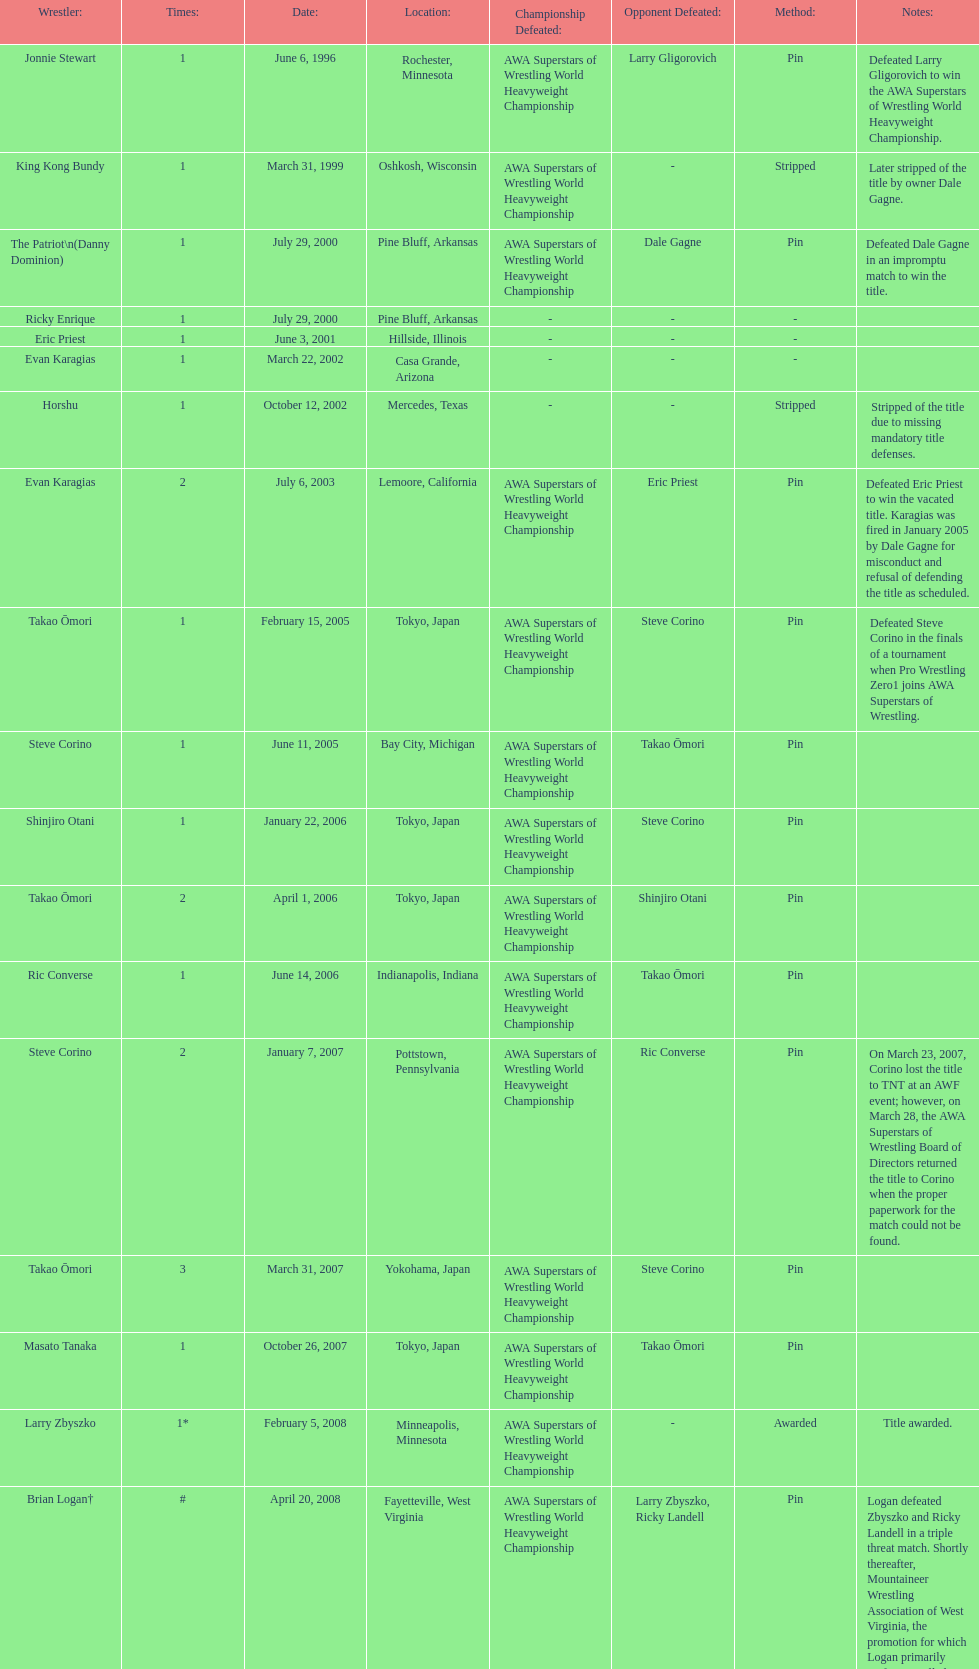How many different men held the wsl title before horshu won his first wsl title? 6. 